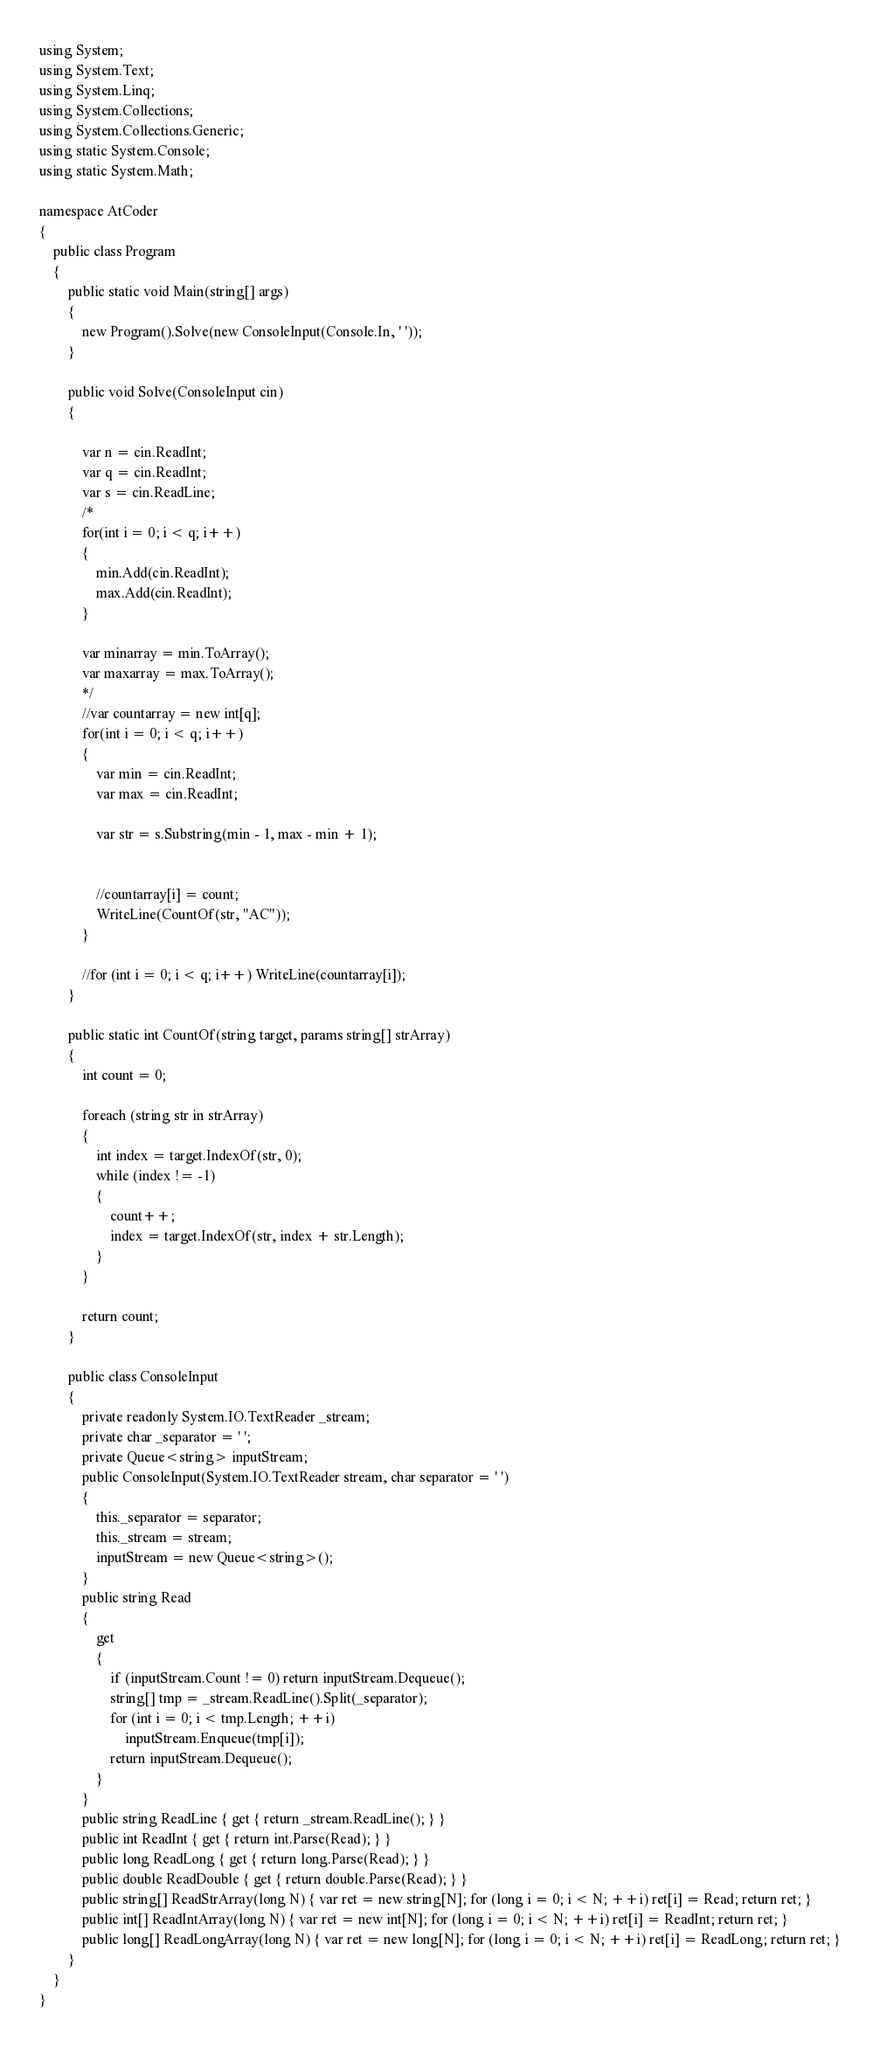Convert code to text. <code><loc_0><loc_0><loc_500><loc_500><_C#_>using System;
using System.Text;
using System.Linq;
using System.Collections;
using System.Collections.Generic;
using static System.Console;
using static System.Math;

namespace AtCoder
{
    public class Program
    {
        public static void Main(string[] args)
        {
            new Program().Solve(new ConsoleInput(Console.In, ' '));
        }

        public void Solve(ConsoleInput cin)
        {

            var n = cin.ReadInt;
            var q = cin.ReadInt;
            var s = cin.ReadLine;
            /*
            for(int i = 0; i < q; i++)
            {
                min.Add(cin.ReadInt);
                max.Add(cin.ReadInt);
            }

            var minarray = min.ToArray();
            var maxarray = max.ToArray();
            */
            //var countarray = new int[q];
            for(int i = 0; i < q; i++)
            {
                var min = cin.ReadInt;
                var max = cin.ReadInt;

                var str = s.Substring(min - 1, max - min + 1);


                //countarray[i] = count;  
                WriteLine(CountOf(str, "AC"));
            }

            //for (int i = 0; i < q; i++) WriteLine(countarray[i]);
        }

        public static int CountOf(string target, params string[] strArray)
        {
            int count = 0;

            foreach (string str in strArray)
            {
                int index = target.IndexOf(str, 0);
                while (index != -1)
                {
                    count++;
                    index = target.IndexOf(str, index + str.Length);
                }
            }

            return count;
        }

        public class ConsoleInput
        {
            private readonly System.IO.TextReader _stream;
            private char _separator = ' ';
            private Queue<string> inputStream;
            public ConsoleInput(System.IO.TextReader stream, char separator = ' ')
            {
                this._separator = separator;
                this._stream = stream;
                inputStream = new Queue<string>();
            }
            public string Read
            {
                get
                {
                    if (inputStream.Count != 0) return inputStream.Dequeue();
                    string[] tmp = _stream.ReadLine().Split(_separator);
                    for (int i = 0; i < tmp.Length; ++i)
                        inputStream.Enqueue(tmp[i]);
                    return inputStream.Dequeue();
                }
            }
            public string ReadLine { get { return _stream.ReadLine(); } }
            public int ReadInt { get { return int.Parse(Read); } }
            public long ReadLong { get { return long.Parse(Read); } }
            public double ReadDouble { get { return double.Parse(Read); } }
            public string[] ReadStrArray(long N) { var ret = new string[N]; for (long i = 0; i < N; ++i) ret[i] = Read; return ret; }
            public int[] ReadIntArray(long N) { var ret = new int[N]; for (long i = 0; i < N; ++i) ret[i] = ReadInt; return ret; }
            public long[] ReadLongArray(long N) { var ret = new long[N]; for (long i = 0; i < N; ++i) ret[i] = ReadLong; return ret; }
        }
    }
}</code> 